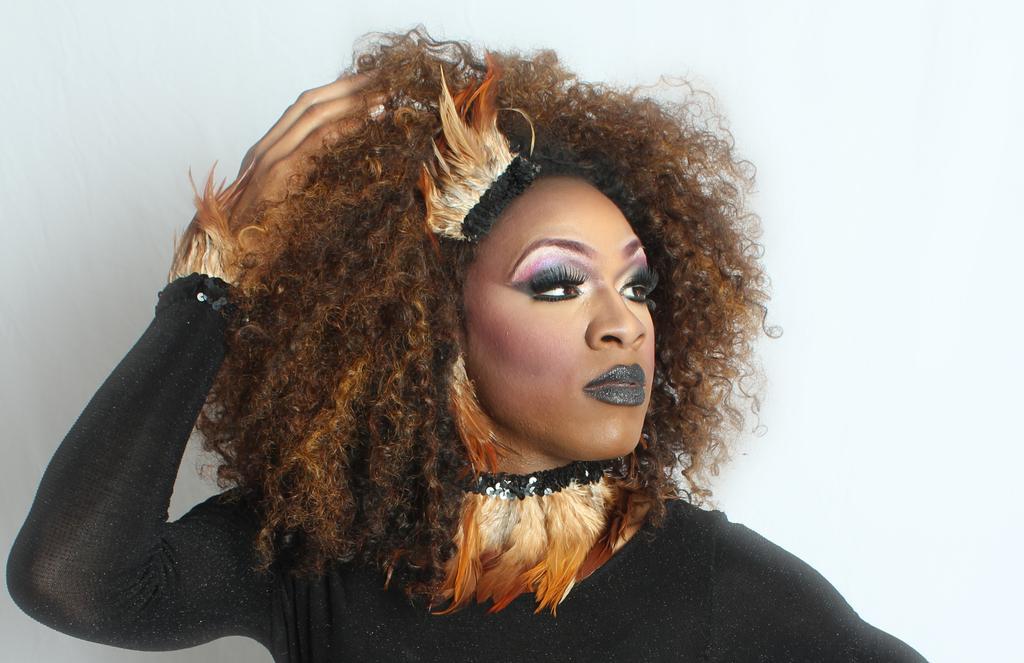Please provide a concise description of this image. In this picture there is a woman who is wearing black dress. She is standing near to the wall. 